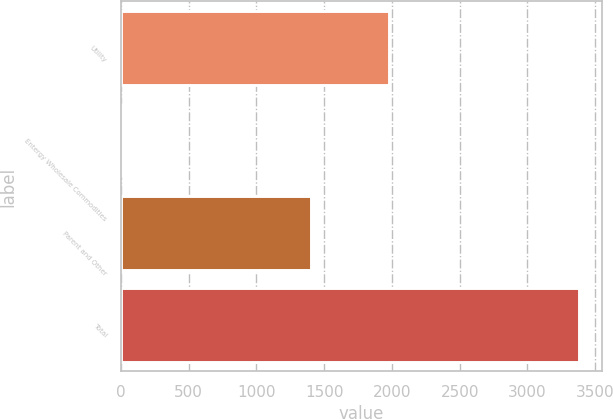<chart> <loc_0><loc_0><loc_500><loc_500><bar_chart><fcel>Utility<fcel>Entergy Wholesale Commodities<fcel>Parent and Other<fcel>Total<nl><fcel>1978<fcel>2<fcel>1403<fcel>3383<nl></chart> 